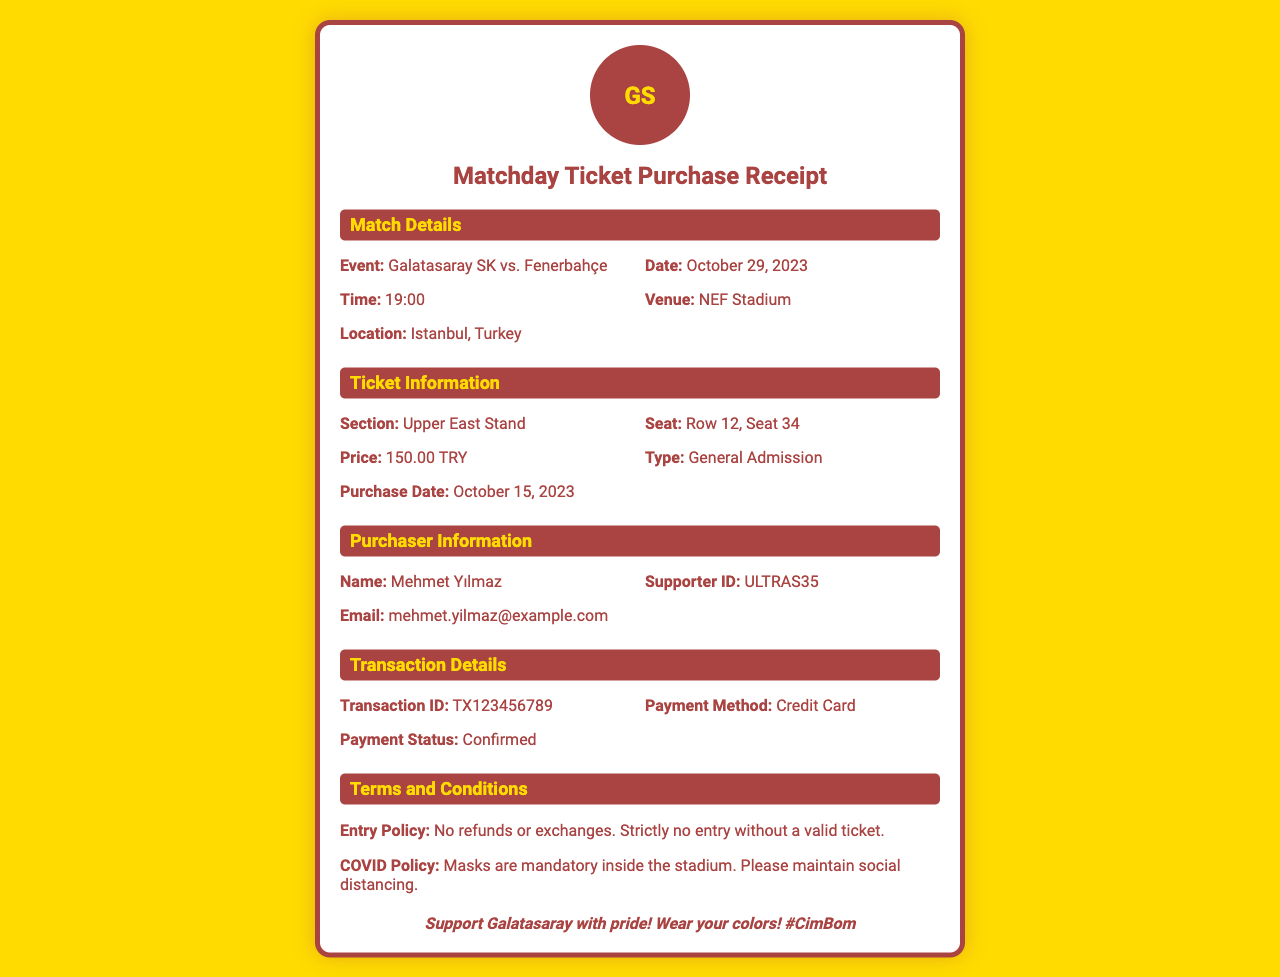What is the event? The event is specified in the match details section of the receipt, showing the teams playing against each other.
Answer: Galatasaray SK vs. Fenerbahçe What is the date of the match? The date is mentioned in the match details section, indicating when the event will take place.
Answer: October 29, 2023 What section is the ticket for? The section for the ticket is listed in the ticket information section of the receipt.
Answer: Upper East Stand What is the seat number? The seat number is provided in the ticket information section and shows the exact seating arrangement.
Answer: Row 12, Seat 34 What is the purchase date? The purchase date is found in the ticket information section, indicating when the ticket was bought.
Answer: October 15, 2023 What is the transaction ID? The transaction ID is outlined in the transaction details section, needed for tracking the purchase.
Answer: TX123456789 What is the payment method? The payment method is specified in the transaction details section of the receipt.
Answer: Credit Card What is the price of the ticket? The ticket price is mentioned in the ticket information section, indicating how much was paid for the admission.
Answer: 150.00 TRY What is the email of the purchaser? The purchaser's email is listed in the purchaser information section for contact purposes.
Answer: mehmet.yilmaz@example.com What is the COVID policy mentioned? The COVID policy is included in the terms and conditions section, providing safety guidelines for attendees.
Answer: Masks are mandatory inside the stadium 